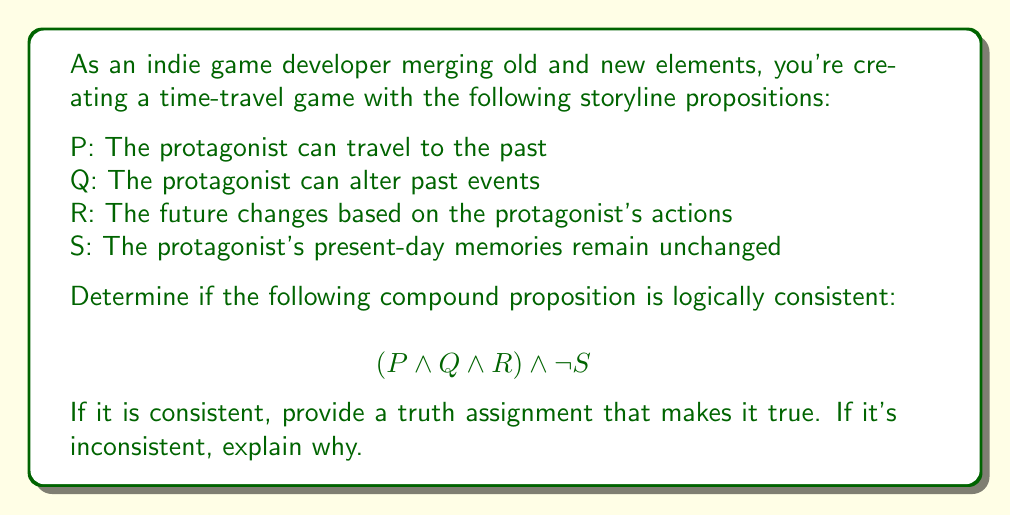Help me with this question. To determine the logical consistency of the compound proposition, we need to evaluate if there exists a truth assignment that makes the entire proposition true. Let's break it down step by step:

1. The compound proposition is: $$(P \land Q \land R) \land \lnot S$$

2. For this to be true, both parts of the conjunction must be true:
   a) $(P \land Q \land R)$ must be true
   b) $\lnot S$ must be true

3. For $(P \land Q \land R)$ to be true:
   - P must be true (protagonist can travel to the past)
   - Q must be true (protagonist can alter past events)
   - R must be true (future changes based on protagonist's actions)

4. For $\lnot S$ to be true:
   - S must be false (protagonist's present-day memories do change)

5. Analyzing the logical consistency:
   - P, Q, and R being true is logically consistent with the concept of time travel and changing the past.
   - However, if R is true (the future changes) and S is false (memories change), this creates a logically consistent scenario where altering the past affects both the future and the protagonist's memories.

6. Truth assignment that makes the compound proposition true:
   P: True
   Q: True
   R: True
   S: False

This truth assignment satisfies all parts of the compound proposition, making it logically consistent.
Answer: The compound proposition $$(P \land Q \land R) \land \lnot S$$ is logically consistent. A truth assignment that makes it true is:
P: True, Q: True, R: True, S: False 